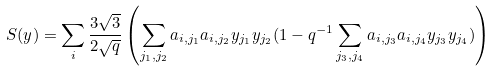Convert formula to latex. <formula><loc_0><loc_0><loc_500><loc_500>S ( y ) & = \sum _ { i } \frac { 3 \sqrt { 3 } } { 2 \sqrt { q } } \left ( \sum _ { j _ { 1 } , j _ { 2 } } a _ { i , j _ { 1 } } a _ { i , j _ { 2 } } y _ { j _ { 1 } } y _ { j _ { 2 } } ( 1 - q ^ { - 1 } \sum _ { j _ { 3 } , j _ { 4 } } a _ { i , j _ { 3 } } a _ { i , j _ { 4 } } y _ { j _ { 3 } } y _ { j _ { 4 } } ) \right )</formula> 